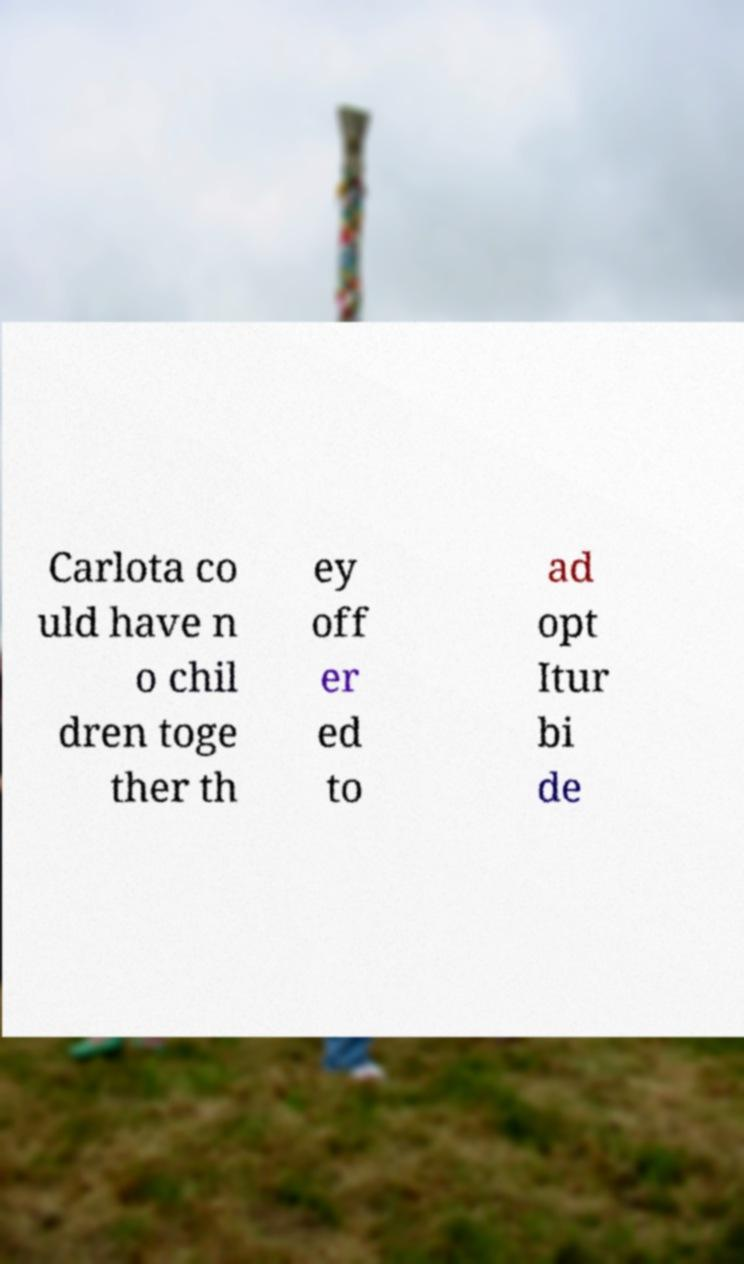Please identify and transcribe the text found in this image. Carlota co uld have n o chil dren toge ther th ey off er ed to ad opt Itur bi de 